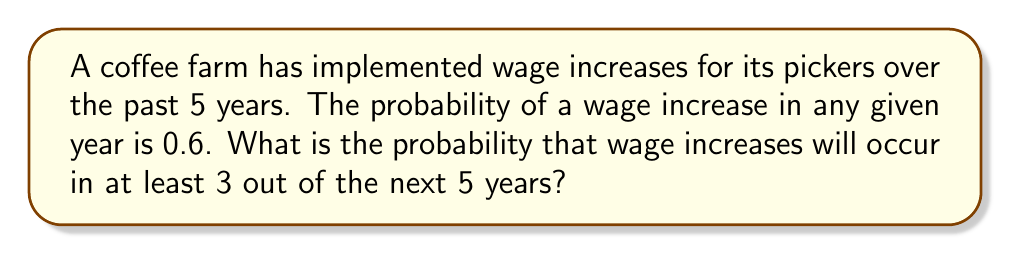Can you solve this math problem? To solve this problem, we can use the binomial probability distribution.

Let X be the number of years with wage increases out of the next 5 years.

We want to find P(X ≥ 3).

The binomial probability formula is:

$$P(X = k) = \binom{n}{k} p^k (1-p)^{n-k}$$

Where:
n = number of trials (5 years)
k = number of successes (3, 4, or 5 wage increases)
p = probability of success in each trial (0.6)

We need to calculate:

$$P(X \geq 3) = P(X = 3) + P(X = 4) + P(X = 5)$$

Step 1: Calculate P(X = 3)
$$P(X = 3) = \binom{5}{3} (0.6)^3 (0.4)^2 = 10 \times 0.216 \times 0.16 = 0.3456$$

Step 2: Calculate P(X = 4)
$$P(X = 4) = \binom{5}{4} (0.6)^4 (0.4)^1 = 5 \times 0.1296 \times 0.4 = 0.2592$$

Step 3: Calculate P(X = 5)
$$P(X = 5) = \binom{5}{5} (0.6)^5 (0.4)^0 = 1 \times 0.07776 \times 1 = 0.07776$$

Step 4: Sum the probabilities
$$P(X \geq 3) = 0.3456 + 0.2592 + 0.07776 = 0.68256$$

Therefore, the probability of wage increases occurring in at least 3 out of the next 5 years is approximately 0.6826 or 68.26%.
Answer: 0.6826 